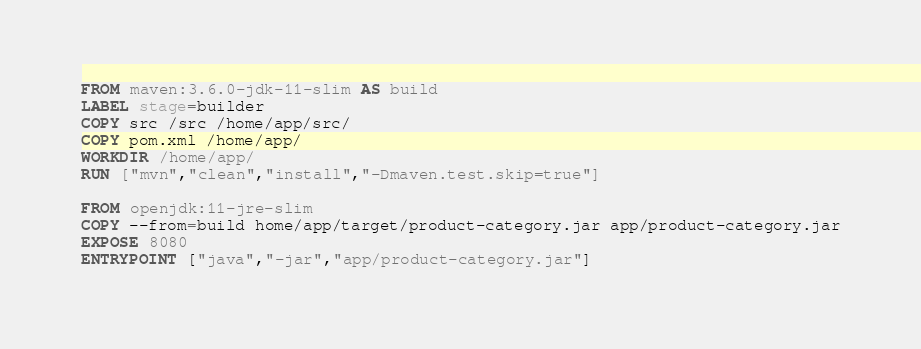Convert code to text. <code><loc_0><loc_0><loc_500><loc_500><_Dockerfile_>FROM maven:3.6.0-jdk-11-slim AS build
LABEL stage=builder
COPY src /src /home/app/src/
COPY pom.xml /home/app/
WORKDIR /home/app/
RUN ["mvn","clean","install","-Dmaven.test.skip=true"]

FROM openjdk:11-jre-slim
COPY --from=build home/app/target/product-category.jar app/product-category.jar
EXPOSE 8080
ENTRYPOINT ["java","-jar","app/product-category.jar"]</code> 